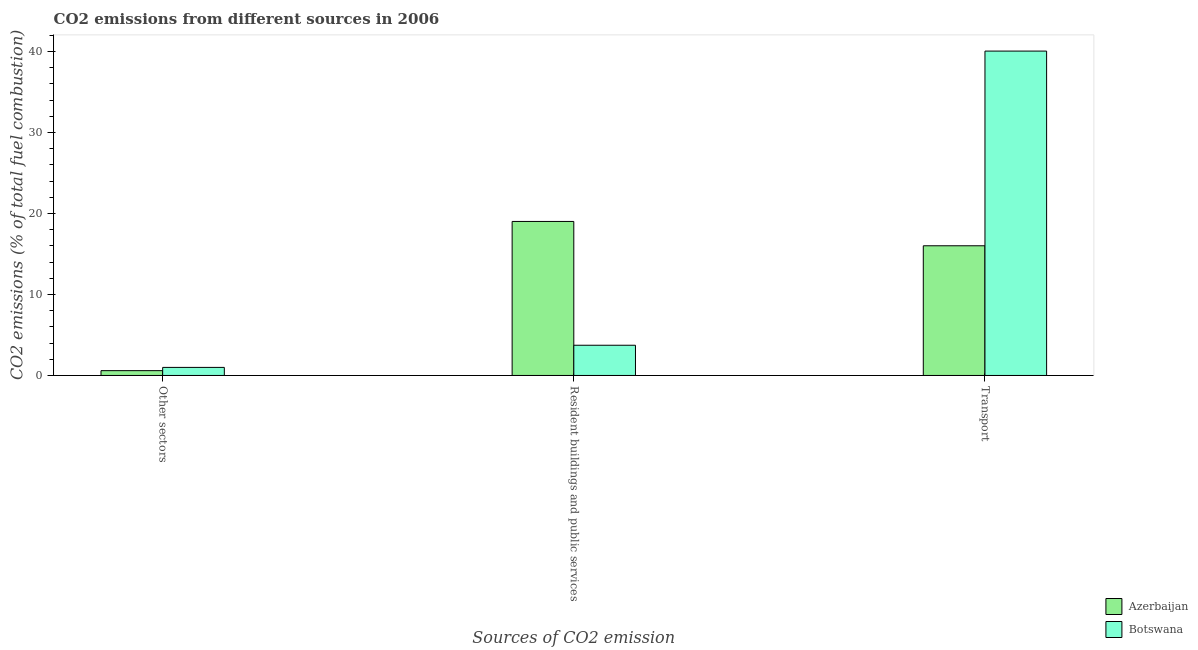How many different coloured bars are there?
Offer a terse response. 2. Are the number of bars on each tick of the X-axis equal?
Give a very brief answer. Yes. How many bars are there on the 3rd tick from the right?
Your response must be concise. 2. What is the label of the 3rd group of bars from the left?
Offer a terse response. Transport. What is the percentage of co2 emissions from transport in Botswana?
Make the answer very short. 40.05. Across all countries, what is the maximum percentage of co2 emissions from other sectors?
Offer a terse response. 1. Across all countries, what is the minimum percentage of co2 emissions from transport?
Ensure brevity in your answer.  16.01. In which country was the percentage of co2 emissions from other sectors maximum?
Provide a succinct answer. Botswana. In which country was the percentage of co2 emissions from resident buildings and public services minimum?
Offer a very short reply. Botswana. What is the total percentage of co2 emissions from transport in the graph?
Offer a very short reply. 56.06. What is the difference between the percentage of co2 emissions from transport in Azerbaijan and that in Botswana?
Provide a short and direct response. -24.04. What is the difference between the percentage of co2 emissions from transport in Botswana and the percentage of co2 emissions from resident buildings and public services in Azerbaijan?
Make the answer very short. 21.03. What is the average percentage of co2 emissions from resident buildings and public services per country?
Make the answer very short. 11.37. What is the difference between the percentage of co2 emissions from transport and percentage of co2 emissions from resident buildings and public services in Botswana?
Ensure brevity in your answer.  36.32. What is the ratio of the percentage of co2 emissions from other sectors in Botswana to that in Azerbaijan?
Your answer should be very brief. 1.67. Is the difference between the percentage of co2 emissions from other sectors in Azerbaijan and Botswana greater than the difference between the percentage of co2 emissions from resident buildings and public services in Azerbaijan and Botswana?
Your answer should be very brief. No. What is the difference between the highest and the second highest percentage of co2 emissions from resident buildings and public services?
Offer a very short reply. 15.28. What is the difference between the highest and the lowest percentage of co2 emissions from transport?
Provide a short and direct response. 24.04. In how many countries, is the percentage of co2 emissions from resident buildings and public services greater than the average percentage of co2 emissions from resident buildings and public services taken over all countries?
Your response must be concise. 1. Is the sum of the percentage of co2 emissions from other sectors in Botswana and Azerbaijan greater than the maximum percentage of co2 emissions from transport across all countries?
Keep it short and to the point. No. What does the 2nd bar from the left in Transport represents?
Provide a succinct answer. Botswana. What does the 1st bar from the right in Other sectors represents?
Provide a short and direct response. Botswana. Is it the case that in every country, the sum of the percentage of co2 emissions from other sectors and percentage of co2 emissions from resident buildings and public services is greater than the percentage of co2 emissions from transport?
Offer a terse response. No. What is the difference between two consecutive major ticks on the Y-axis?
Provide a short and direct response. 10. How many legend labels are there?
Your response must be concise. 2. How are the legend labels stacked?
Ensure brevity in your answer.  Vertical. What is the title of the graph?
Your answer should be compact. CO2 emissions from different sources in 2006. Does "Latin America(all income levels)" appear as one of the legend labels in the graph?
Ensure brevity in your answer.  No. What is the label or title of the X-axis?
Provide a succinct answer. Sources of CO2 emission. What is the label or title of the Y-axis?
Ensure brevity in your answer.  CO2 emissions (% of total fuel combustion). What is the CO2 emissions (% of total fuel combustion) in Azerbaijan in Other sectors?
Give a very brief answer. 0.59. What is the CO2 emissions (% of total fuel combustion) in Botswana in Other sectors?
Provide a short and direct response. 1. What is the CO2 emissions (% of total fuel combustion) in Azerbaijan in Resident buildings and public services?
Your answer should be very brief. 19.02. What is the CO2 emissions (% of total fuel combustion) of Botswana in Resident buildings and public services?
Keep it short and to the point. 3.73. What is the CO2 emissions (% of total fuel combustion) of Azerbaijan in Transport?
Your answer should be very brief. 16.01. What is the CO2 emissions (% of total fuel combustion) of Botswana in Transport?
Your answer should be very brief. 40.05. Across all Sources of CO2 emission, what is the maximum CO2 emissions (% of total fuel combustion) in Azerbaijan?
Give a very brief answer. 19.02. Across all Sources of CO2 emission, what is the maximum CO2 emissions (% of total fuel combustion) of Botswana?
Offer a terse response. 40.05. Across all Sources of CO2 emission, what is the minimum CO2 emissions (% of total fuel combustion) in Azerbaijan?
Provide a short and direct response. 0.59. Across all Sources of CO2 emission, what is the minimum CO2 emissions (% of total fuel combustion) of Botswana?
Provide a succinct answer. 1. What is the total CO2 emissions (% of total fuel combustion) of Azerbaijan in the graph?
Make the answer very short. 35.62. What is the total CO2 emissions (% of total fuel combustion) of Botswana in the graph?
Give a very brief answer. 44.78. What is the difference between the CO2 emissions (% of total fuel combustion) of Azerbaijan in Other sectors and that in Resident buildings and public services?
Make the answer very short. -18.42. What is the difference between the CO2 emissions (% of total fuel combustion) in Botswana in Other sectors and that in Resident buildings and public services?
Your answer should be very brief. -2.74. What is the difference between the CO2 emissions (% of total fuel combustion) in Azerbaijan in Other sectors and that in Transport?
Provide a short and direct response. -15.42. What is the difference between the CO2 emissions (% of total fuel combustion) of Botswana in Other sectors and that in Transport?
Ensure brevity in your answer.  -39.05. What is the difference between the CO2 emissions (% of total fuel combustion) of Azerbaijan in Resident buildings and public services and that in Transport?
Your answer should be compact. 3. What is the difference between the CO2 emissions (% of total fuel combustion) in Botswana in Resident buildings and public services and that in Transport?
Ensure brevity in your answer.  -36.32. What is the difference between the CO2 emissions (% of total fuel combustion) in Azerbaijan in Other sectors and the CO2 emissions (% of total fuel combustion) in Botswana in Resident buildings and public services?
Keep it short and to the point. -3.14. What is the difference between the CO2 emissions (% of total fuel combustion) of Azerbaijan in Other sectors and the CO2 emissions (% of total fuel combustion) of Botswana in Transport?
Offer a terse response. -39.46. What is the difference between the CO2 emissions (% of total fuel combustion) in Azerbaijan in Resident buildings and public services and the CO2 emissions (% of total fuel combustion) in Botswana in Transport?
Offer a terse response. -21.03. What is the average CO2 emissions (% of total fuel combustion) in Azerbaijan per Sources of CO2 emission?
Provide a succinct answer. 11.87. What is the average CO2 emissions (% of total fuel combustion) of Botswana per Sources of CO2 emission?
Ensure brevity in your answer.  14.93. What is the difference between the CO2 emissions (% of total fuel combustion) of Azerbaijan and CO2 emissions (% of total fuel combustion) of Botswana in Other sectors?
Provide a succinct answer. -0.4. What is the difference between the CO2 emissions (% of total fuel combustion) of Azerbaijan and CO2 emissions (% of total fuel combustion) of Botswana in Resident buildings and public services?
Provide a succinct answer. 15.28. What is the difference between the CO2 emissions (% of total fuel combustion) in Azerbaijan and CO2 emissions (% of total fuel combustion) in Botswana in Transport?
Give a very brief answer. -24.04. What is the ratio of the CO2 emissions (% of total fuel combustion) of Azerbaijan in Other sectors to that in Resident buildings and public services?
Make the answer very short. 0.03. What is the ratio of the CO2 emissions (% of total fuel combustion) in Botswana in Other sectors to that in Resident buildings and public services?
Your answer should be compact. 0.27. What is the ratio of the CO2 emissions (% of total fuel combustion) of Azerbaijan in Other sectors to that in Transport?
Provide a short and direct response. 0.04. What is the ratio of the CO2 emissions (% of total fuel combustion) in Botswana in Other sectors to that in Transport?
Offer a terse response. 0.02. What is the ratio of the CO2 emissions (% of total fuel combustion) of Azerbaijan in Resident buildings and public services to that in Transport?
Give a very brief answer. 1.19. What is the ratio of the CO2 emissions (% of total fuel combustion) in Botswana in Resident buildings and public services to that in Transport?
Offer a very short reply. 0.09. What is the difference between the highest and the second highest CO2 emissions (% of total fuel combustion) in Azerbaijan?
Offer a very short reply. 3. What is the difference between the highest and the second highest CO2 emissions (% of total fuel combustion) in Botswana?
Keep it short and to the point. 36.32. What is the difference between the highest and the lowest CO2 emissions (% of total fuel combustion) in Azerbaijan?
Your response must be concise. 18.42. What is the difference between the highest and the lowest CO2 emissions (% of total fuel combustion) in Botswana?
Ensure brevity in your answer.  39.05. 